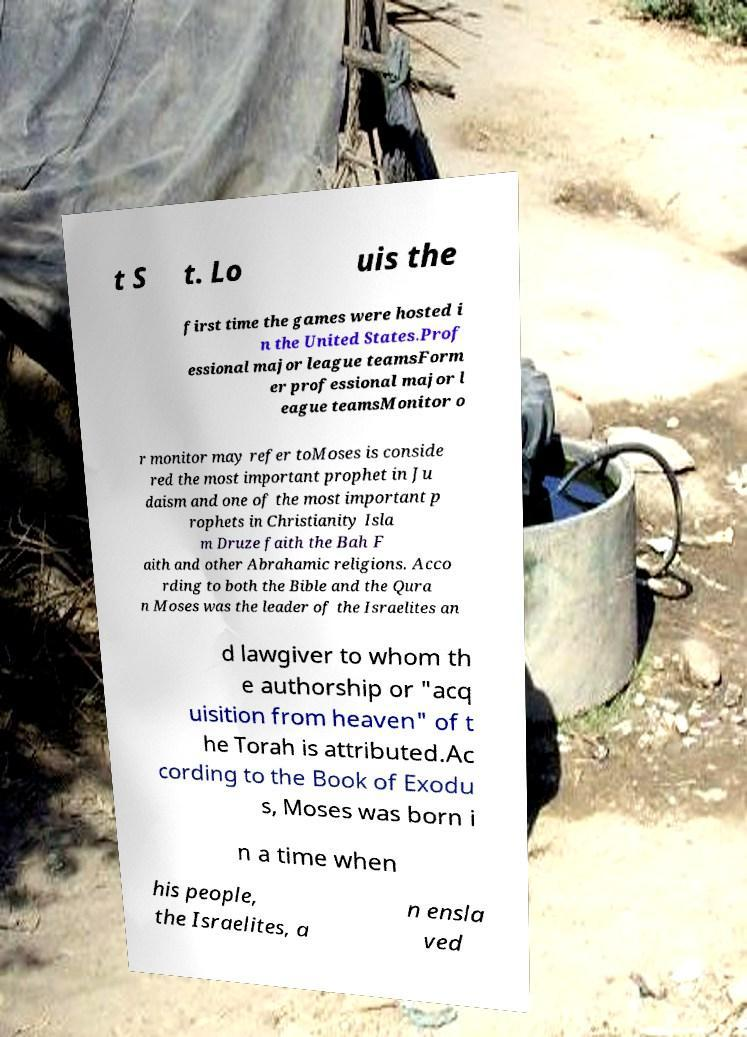Can you read and provide the text displayed in the image?This photo seems to have some interesting text. Can you extract and type it out for me? t S t. Lo uis the first time the games were hosted i n the United States.Prof essional major league teamsForm er professional major l eague teamsMonitor o r monitor may refer toMoses is conside red the most important prophet in Ju daism and one of the most important p rophets in Christianity Isla m Druze faith the Bah F aith and other Abrahamic religions. Acco rding to both the Bible and the Qura n Moses was the leader of the Israelites an d lawgiver to whom th e authorship or "acq uisition from heaven" of t he Torah is attributed.Ac cording to the Book of Exodu s, Moses was born i n a time when his people, the Israelites, a n ensla ved 